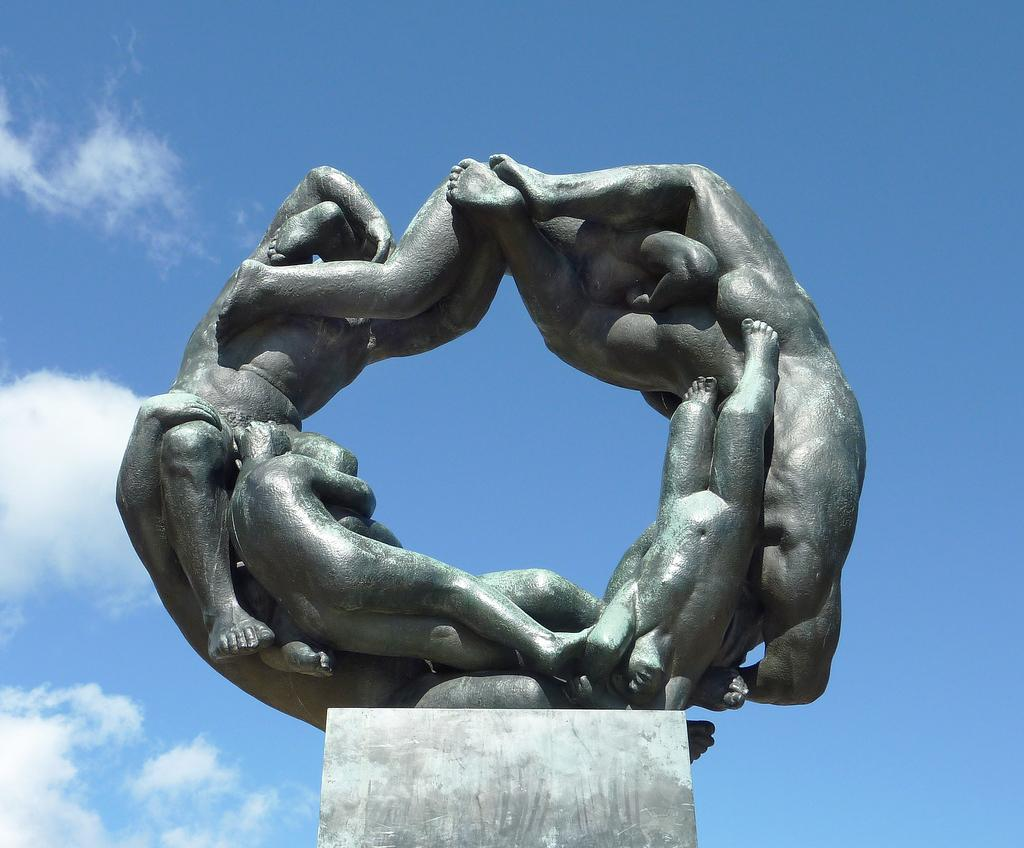What is the main subject of the image? There is a statue on a pillar in the image. What can be seen in the background of the image? There are clouds visible in the background of the image. What type of stocking is the statue wearing in the image? The statue is not wearing any stockings in the image, as it is a sculpture and not a person. 